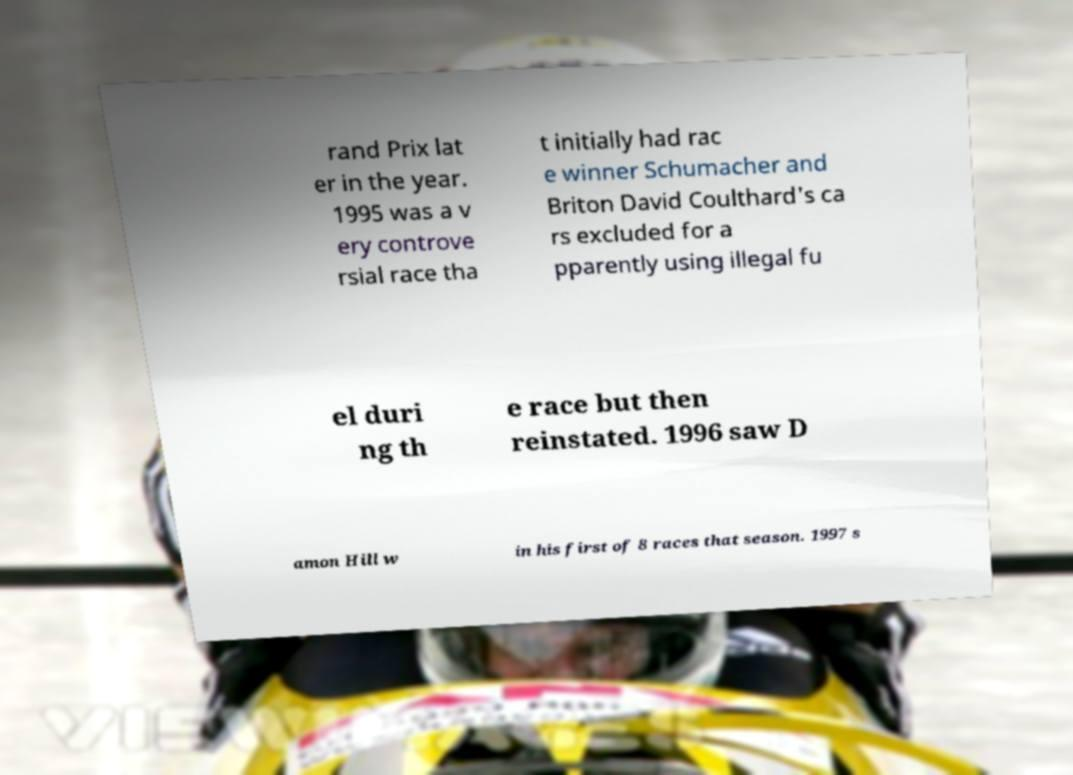Can you accurately transcribe the text from the provided image for me? rand Prix lat er in the year. 1995 was a v ery controve rsial race tha t initially had rac e winner Schumacher and Briton David Coulthard's ca rs excluded for a pparently using illegal fu el duri ng th e race but then reinstated. 1996 saw D amon Hill w in his first of 8 races that season. 1997 s 